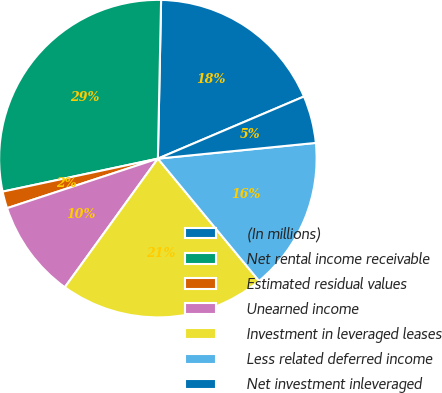Convert chart to OTSL. <chart><loc_0><loc_0><loc_500><loc_500><pie_chart><fcel>(In millions)<fcel>Net rental income receivable<fcel>Estimated residual values<fcel>Unearned income<fcel>Investment in leveraged leases<fcel>Less related deferred income<fcel>Net investment inleveraged<nl><fcel>18.28%<fcel>28.66%<fcel>1.72%<fcel>9.98%<fcel>20.97%<fcel>15.58%<fcel>4.82%<nl></chart> 